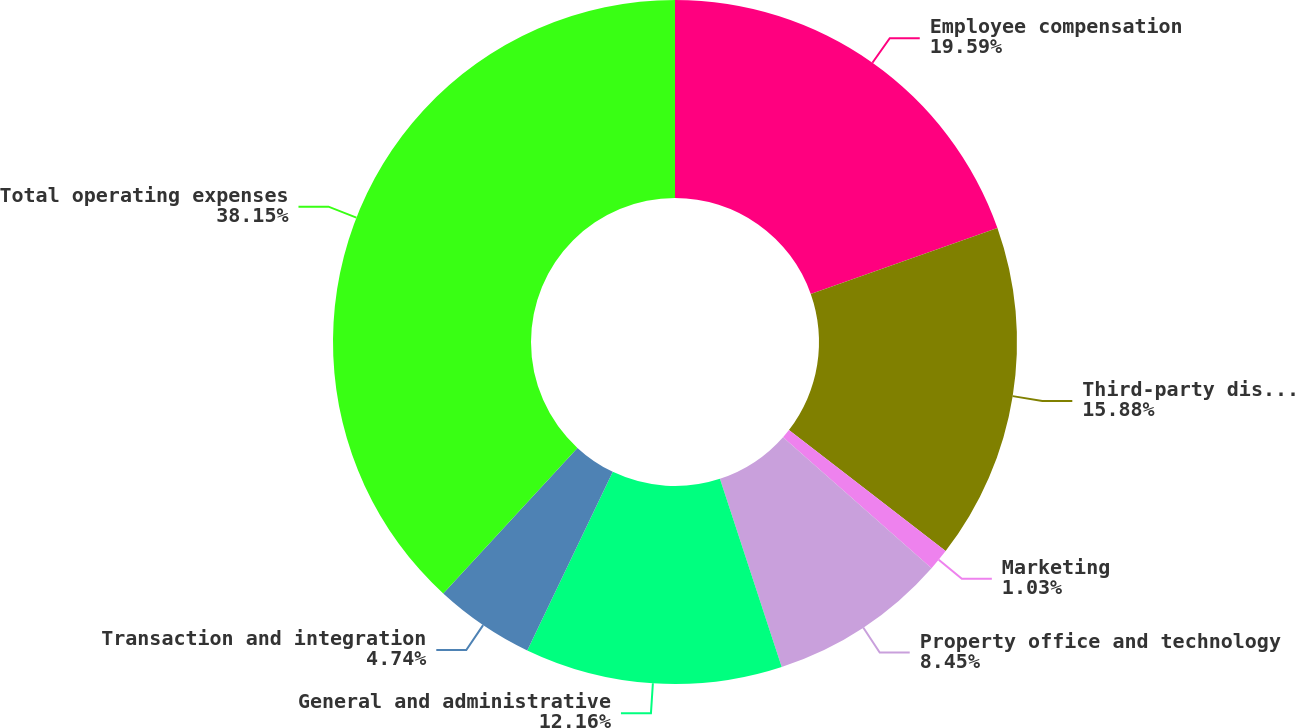Convert chart to OTSL. <chart><loc_0><loc_0><loc_500><loc_500><pie_chart><fcel>Employee compensation<fcel>Third-party distribution<fcel>Marketing<fcel>Property office and technology<fcel>General and administrative<fcel>Transaction and integration<fcel>Total operating expenses<nl><fcel>19.59%<fcel>15.88%<fcel>1.03%<fcel>8.45%<fcel>12.16%<fcel>4.74%<fcel>38.15%<nl></chart> 